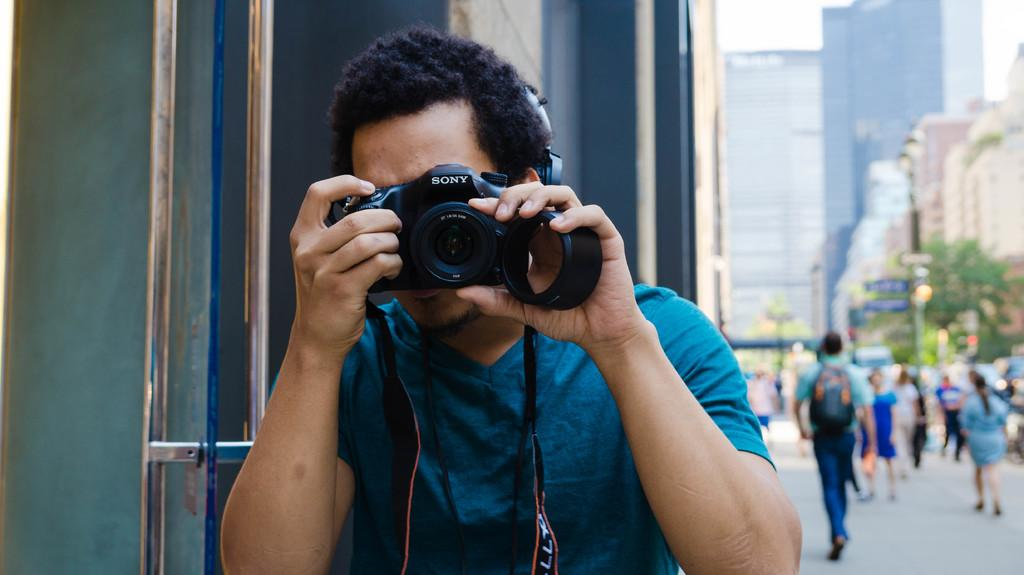What is the person in the image doing? The person is holding a camera and capturing an image. What can be seen in the background of the image? There are buildings visible in the image. What is happening on the road in the image? There are people walking on the road in the image. What type of vegetation is present in the image? There are trees in the image. How many teeth can be seen in the image? There are no teeth visible in the image. What day of the week is it in the image? The day of the week cannot be determined from the image. 